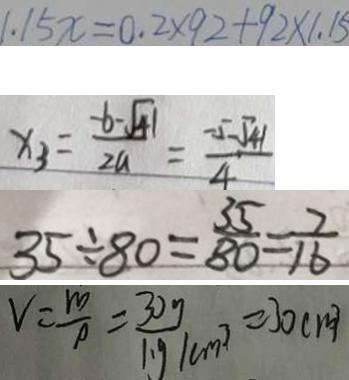<formula> <loc_0><loc_0><loc_500><loc_500>1 . 1 5 x = 0 . 2 \times 9 2 + 9 2 \times 1 . 1 5 
 x _ { 3 } = \frac { - b - \sqrt { 4 1 } } { 2 a } = \frac { - 5 - \sqrt { 4 1 } } { 4 } 
 3 5 \div 8 0 = \frac { 3 5 } { 8 0 } = \frac { 7 } { 1 6 } 
 v = \frac { m } { \rho } = \frac { 3 0 g } { 1 \cdot g / m ^ { 3 } } = 3 0 c m ^ { 3 }</formula> 